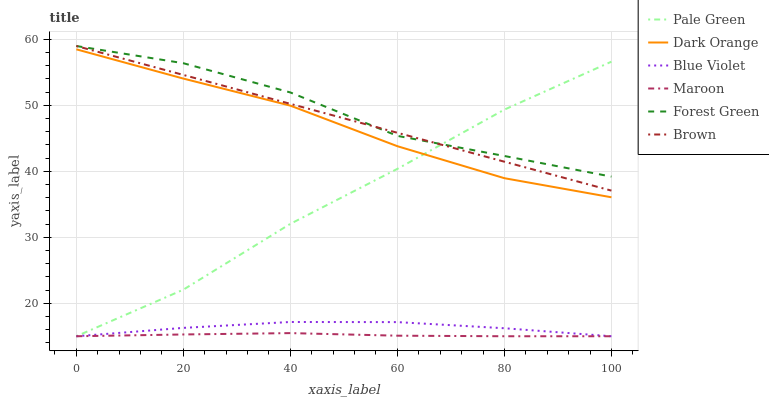Does Maroon have the minimum area under the curve?
Answer yes or no. Yes. Does Forest Green have the maximum area under the curve?
Answer yes or no. Yes. Does Brown have the minimum area under the curve?
Answer yes or no. No. Does Brown have the maximum area under the curve?
Answer yes or no. No. Is Brown the smoothest?
Answer yes or no. Yes. Is Forest Green the roughest?
Answer yes or no. Yes. Is Maroon the smoothest?
Answer yes or no. No. Is Maroon the roughest?
Answer yes or no. No. Does Maroon have the lowest value?
Answer yes or no. Yes. Does Brown have the lowest value?
Answer yes or no. No. Does Forest Green have the highest value?
Answer yes or no. Yes. Does Maroon have the highest value?
Answer yes or no. No. Is Dark Orange less than Brown?
Answer yes or no. Yes. Is Brown greater than Blue Violet?
Answer yes or no. Yes. Does Forest Green intersect Brown?
Answer yes or no. Yes. Is Forest Green less than Brown?
Answer yes or no. No. Is Forest Green greater than Brown?
Answer yes or no. No. Does Dark Orange intersect Brown?
Answer yes or no. No. 